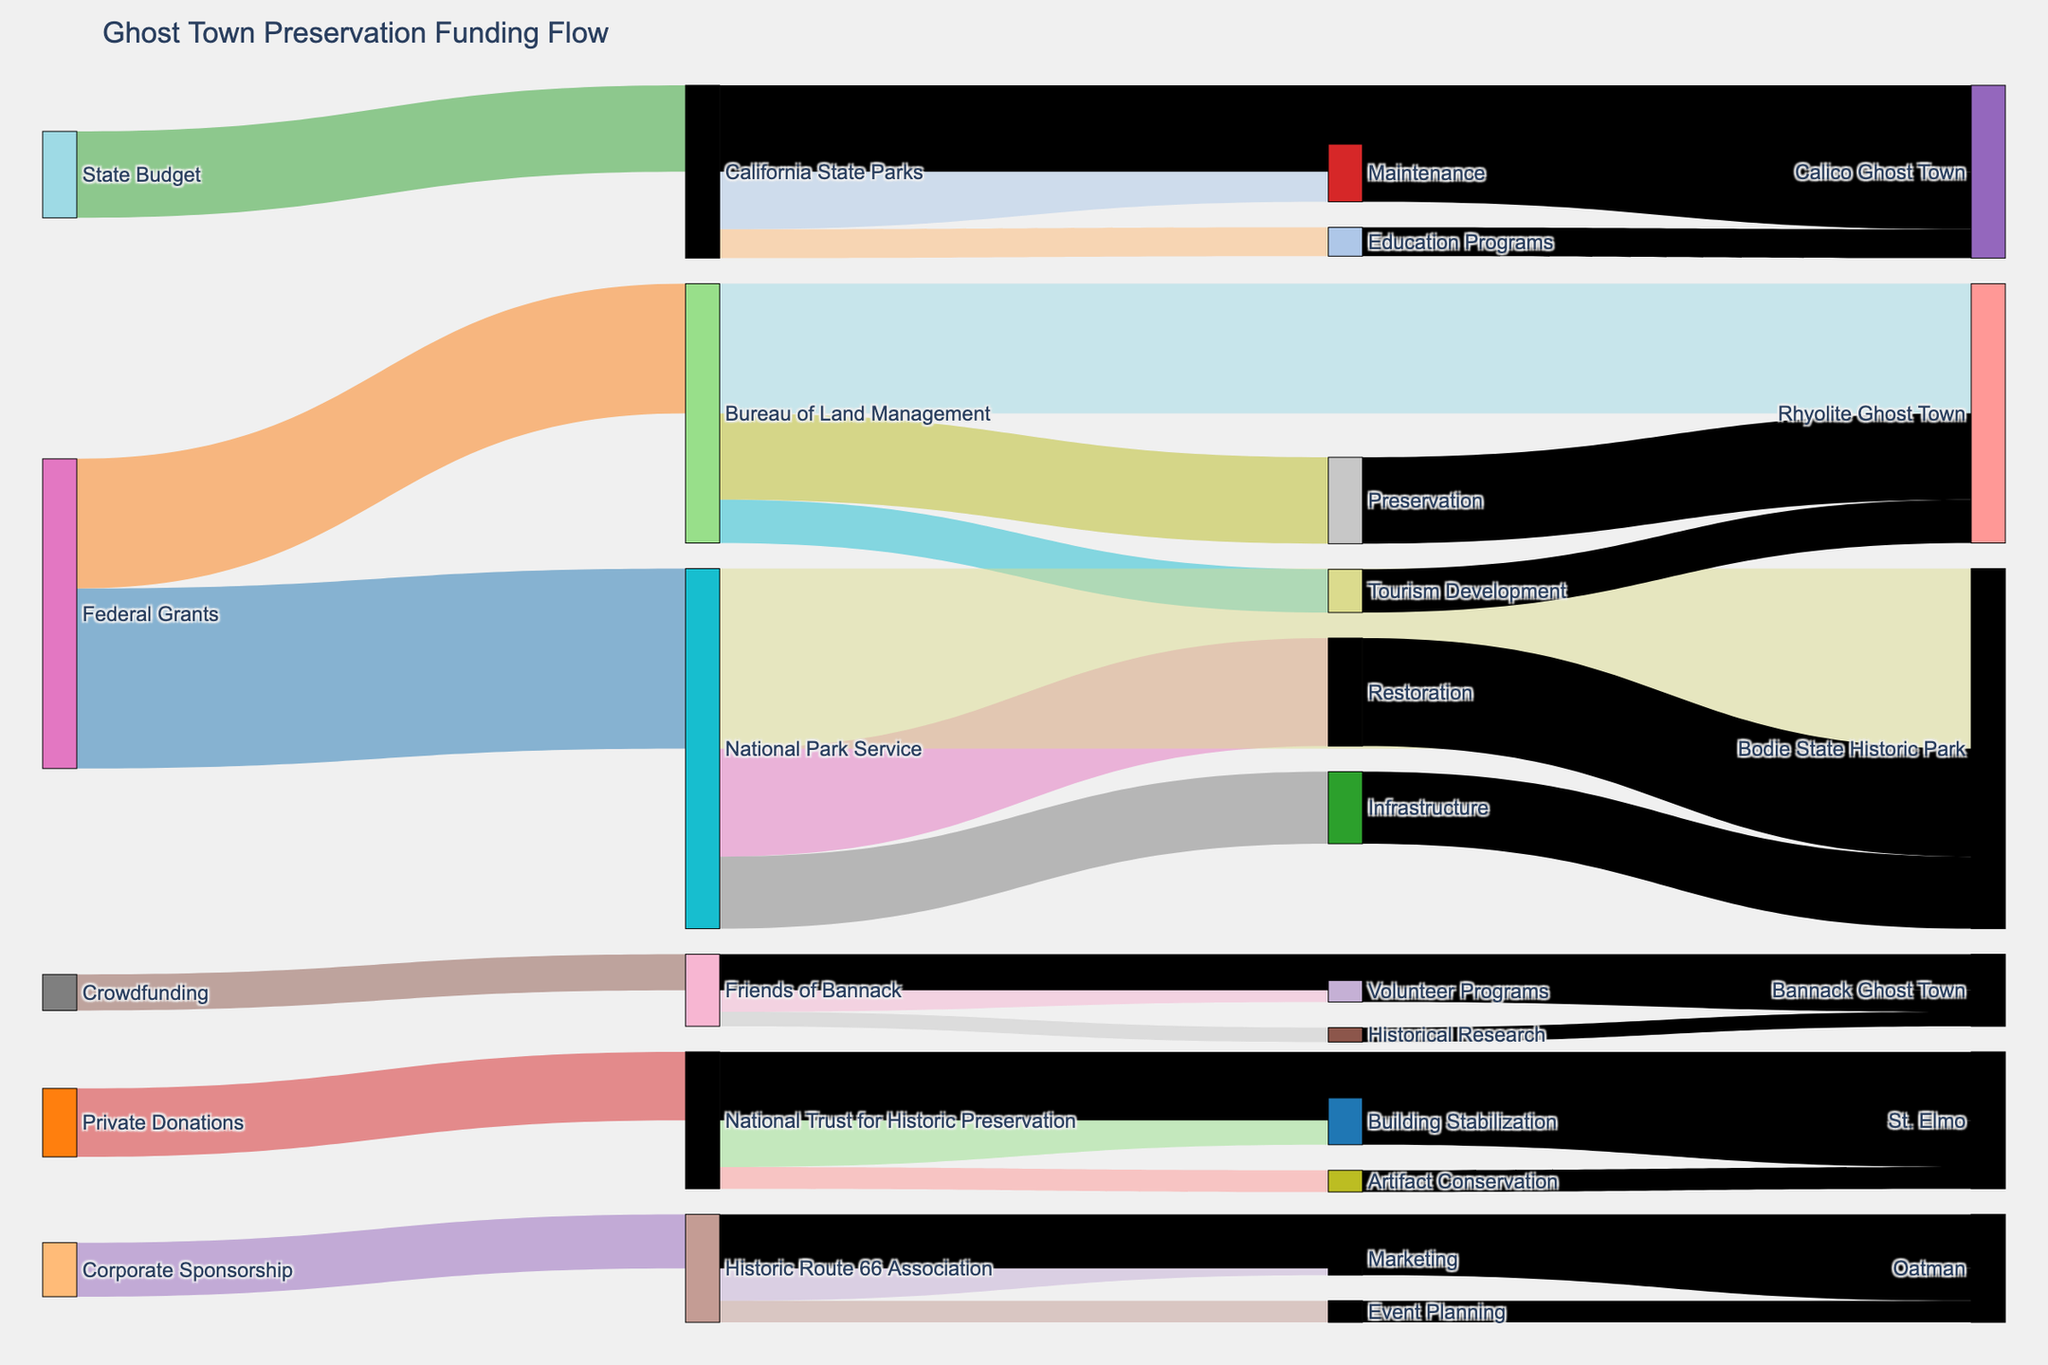Which funding source contributes the most to preservation efforts? By scanning the curved paths, it's clear that "Federal Grants" have the largest flow values. The sum of $2,500,000 for Bodie State Historic Park and $1,800,000 for Rhyolite Ghost Town ensures "Federal Grants" is the highest contributor in total funding.
Answer: Federal Grants How much funding does the National Park Service allocate to Bodie State Historic Park? The National Park Service allocates $1,500,000 for Restoration and $1,000,000 for Infrastructure. Therefore, the total allocation is $1,500,000 + $1,000,000 = $2,500,000.
Answer: $2,500,000 Which ghost town receives the least amount of funding? By comparing the end nodes linked with resource values, Bannack Ghost Town receives a total of $500,000. This is less than any other town listed.
Answer: Bannack Ghost Town Compare the funding received by Calico Ghost Town to that of St. Elmo. Which one receives more total funding? Calico Ghost Town receives $1,200,000 from the California State Parks, while St. Elmo receives $950,000 from the National Trust for Historic Preservation. Calico’s funding is higher.
Answer: Calico Ghost Town What is the total allocation to the Rhyolite Ghost Town from the Bureau of Land Management? The Bureau of Land Management allocates $1,200,000 for Preservation and $600,000 for Tourism Development, giving a total of $1,200,000 + $600,000 = $1,800,000.
Answer: $1,800,000 What is the primary purpose of the funds donated by Corporate Sponsorships? From the diagram, Corporate Sponsorships go to the Historic Route 66 Association, which allocates $450,000 toward Marketing and $300,000 toward Event Planning. The larger amount is allocated to Marketing.
Answer: Marketing How much funding comes from private donations? Private Donations provide $950,000 directed to the National Trust for Historic Preservation.
Answer: $950,000 Which preservation activity receives the highest amount of financial support? Among the listed activities, "Restoration" for Bodie State Historic Park receives $1,500,000, which is the highest of all activities.
Answer: Restoration What is the sum of funding allocated to education and volunteer programs for all ghost towns combined? Education Programs for Calico Ghost Town receive $400,000 and Volunteer Programs for Bannack Ghost Town receive $300,000. Their sum is $400,000 + $300,000 = $700,000.
Answer: $700,000 